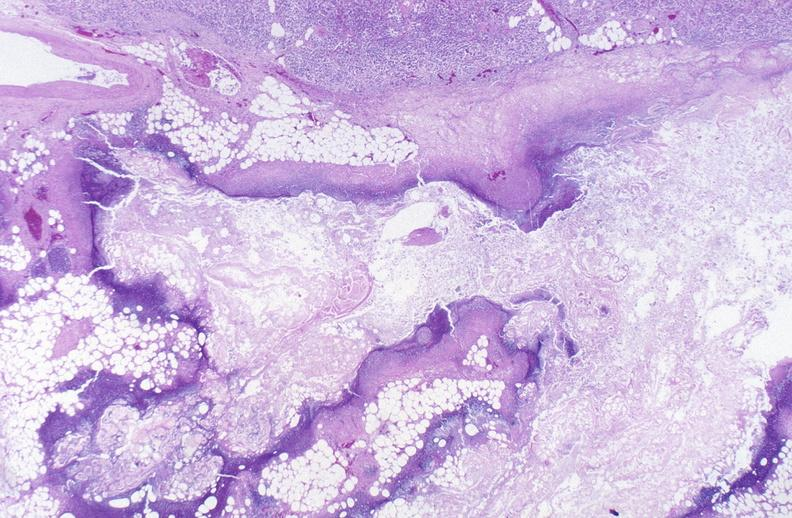what does this image show?
Answer the question using a single word or phrase. Pancreatic fat necrosis 